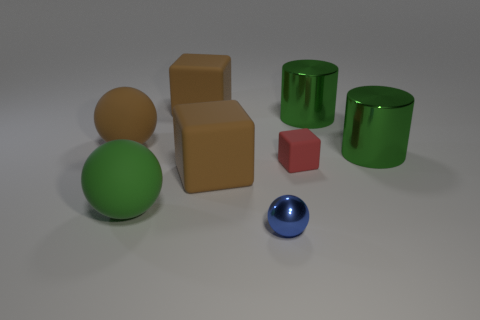The shiny sphere that is the same size as the red rubber cube is what color?
Ensure brevity in your answer.  Blue. How many objects are either large matte spheres that are on the left side of the green sphere or things that are on the left side of the tiny red matte object?
Make the answer very short. 5. Are there an equal number of rubber blocks in front of the tiny shiny sphere and large brown blocks?
Offer a terse response. No. There is a ball in front of the big green rubber sphere; is its size the same as the green object in front of the red rubber cube?
Provide a succinct answer. No. How many other objects are the same size as the blue object?
Make the answer very short. 1. Is there a large green rubber object behind the big block that is behind the tiny object that is to the right of the blue metallic object?
Offer a very short reply. No. Are there any other things that have the same color as the tiny metal sphere?
Your answer should be very brief. No. What is the size of the brown thing that is behind the big brown matte sphere?
Your answer should be compact. Large. There is a ball on the right side of the big cube on the right side of the brown block behind the small matte thing; what size is it?
Your response must be concise. Small. There is a block that is right of the metallic ball left of the tiny block; what color is it?
Provide a succinct answer. Red. 